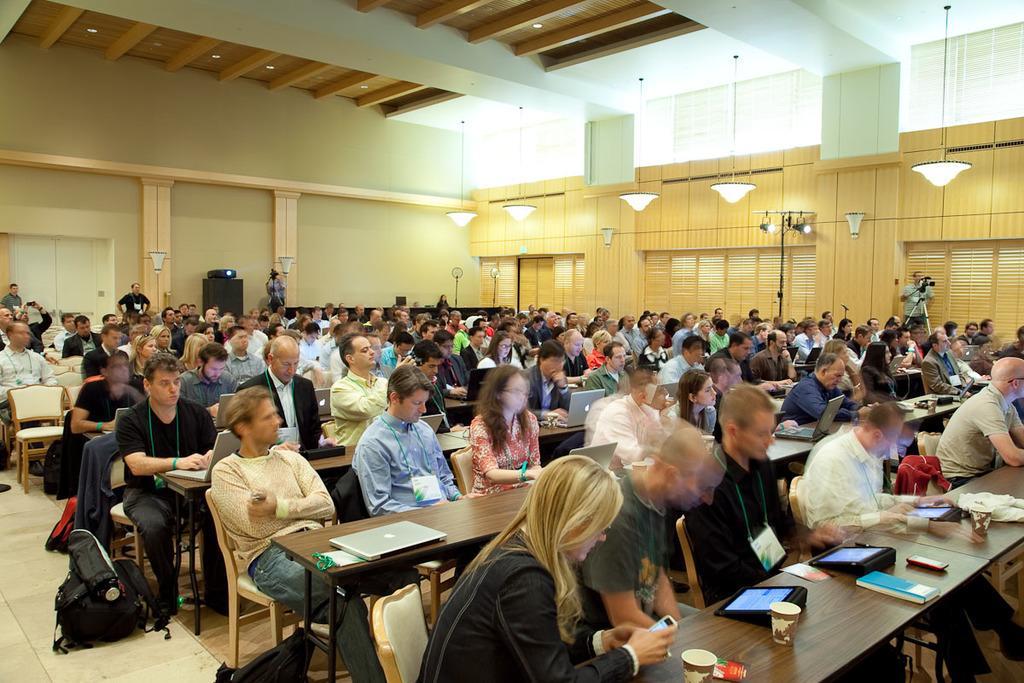Can you describe this image briefly? This picture is taken inside a classroom. There are many people in the image. There are chairs and tables. On the table there are laptops, tabloids, books and paper cups. Everyone in the image are wearing identity cards. There are lights and bulbs hanging from the ceiling. At the right there is a man standing and in front of him there is a camera on the tripod stand. In the background there are people standing at the wall and there is box. 